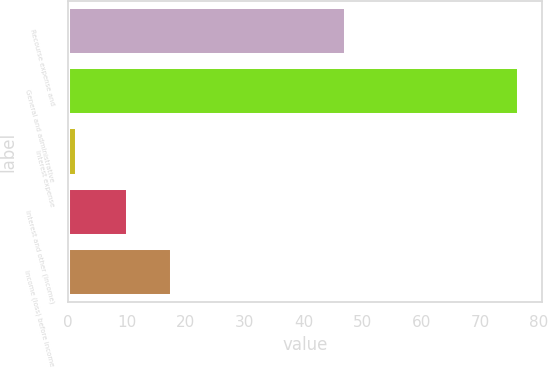Convert chart. <chart><loc_0><loc_0><loc_500><loc_500><bar_chart><fcel>Recourse expense and<fcel>General and administrative<fcel>Interest expense<fcel>Interest and other (income)<fcel>Income (loss) before income<nl><fcel>47.2<fcel>76.7<fcel>1.5<fcel>10.2<fcel>17.72<nl></chart> 